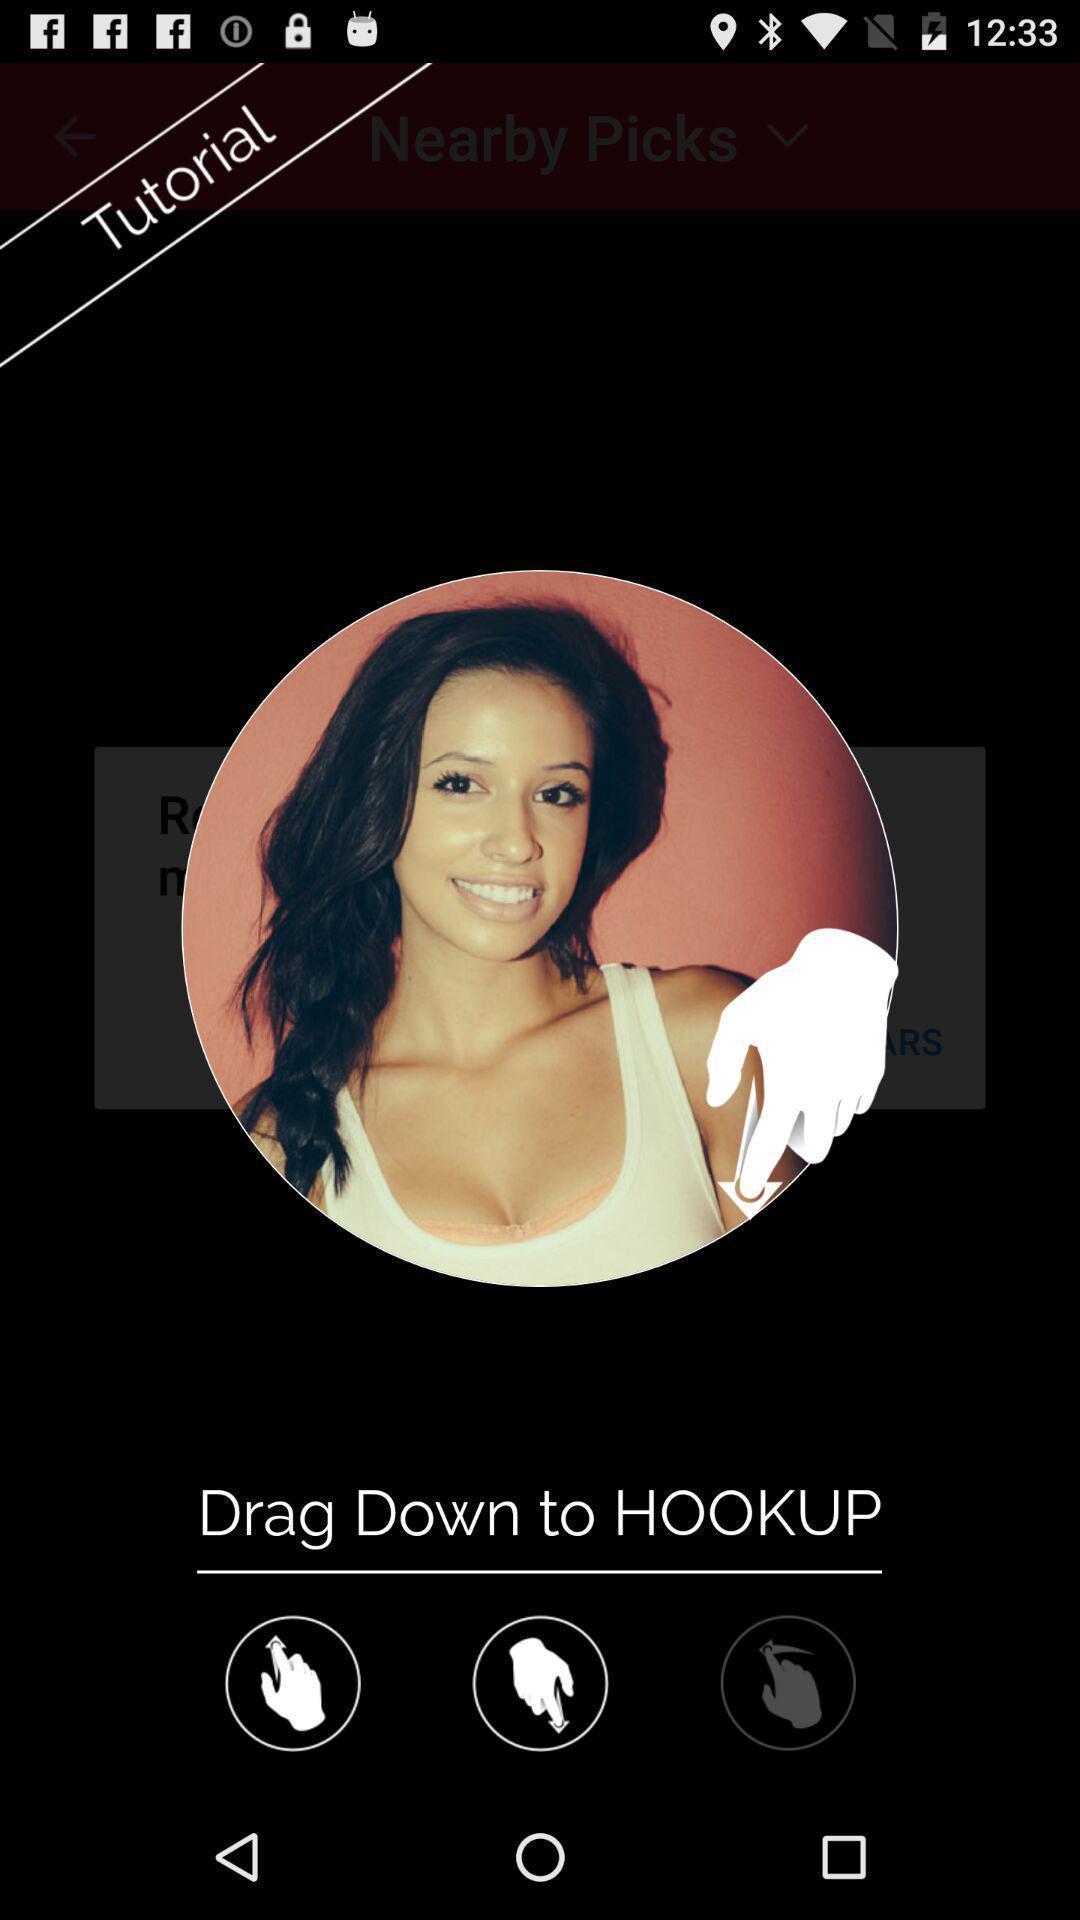Provide a textual representation of this image. Page displaying with a image and few options to edit. 